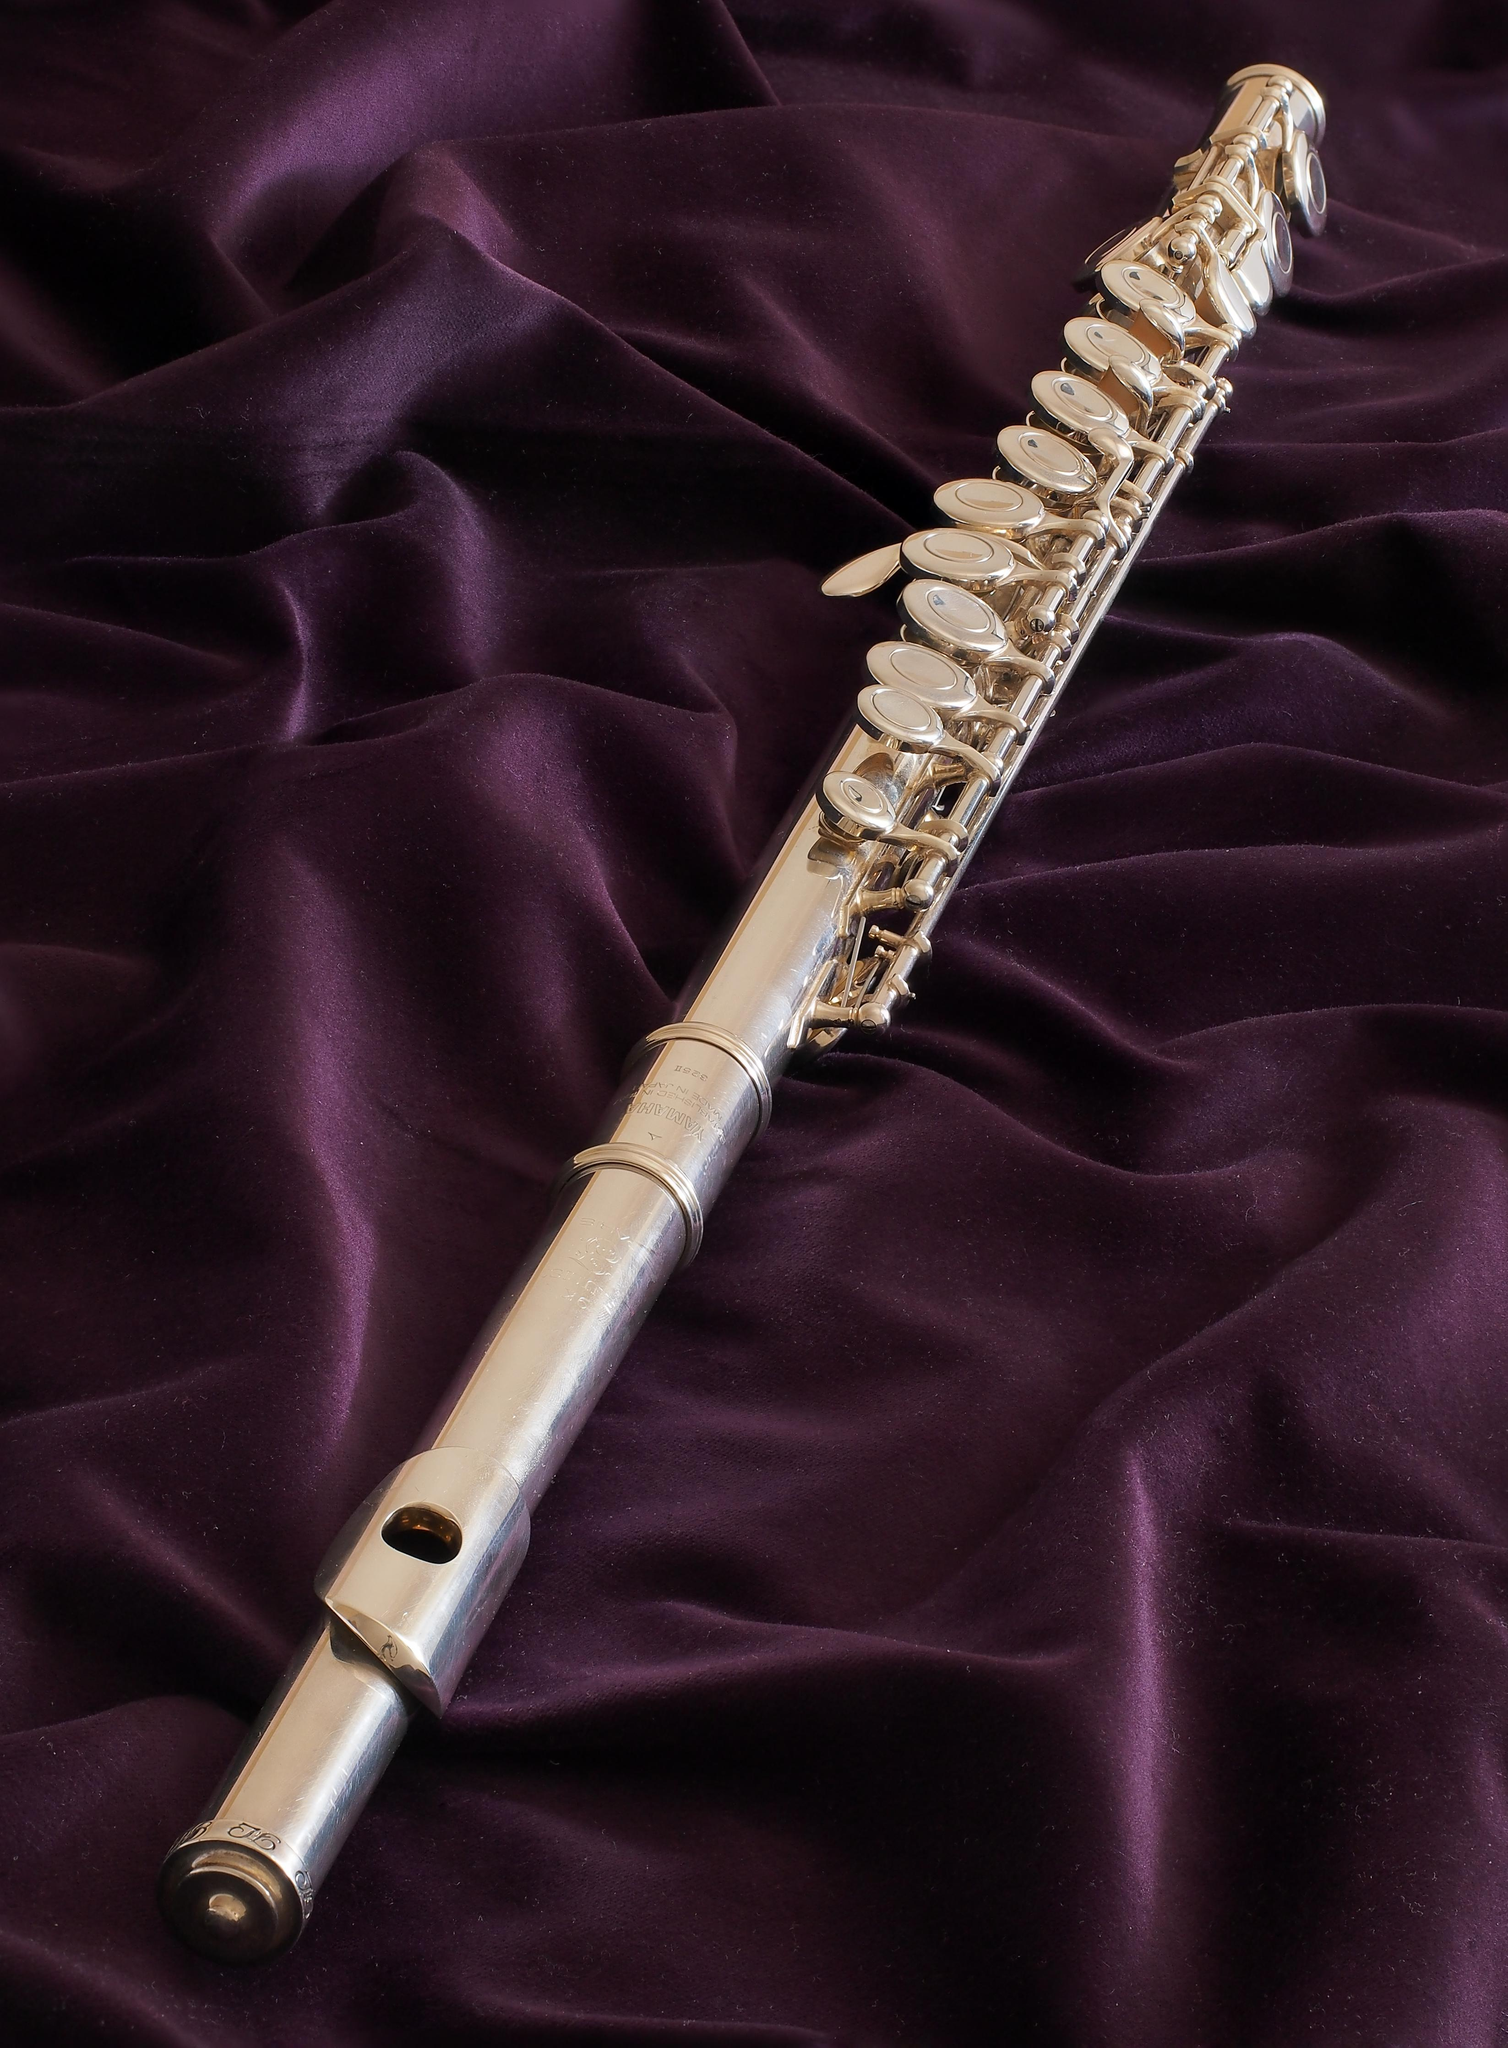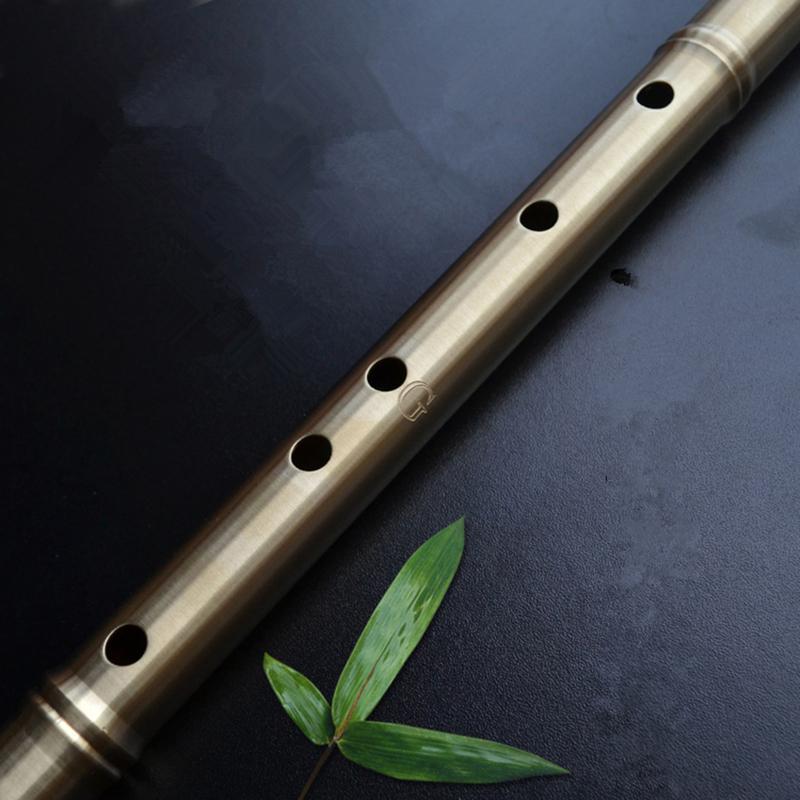The first image is the image on the left, the second image is the image on the right. Considering the images on both sides, is "The picture on the left shows exactly two flutes side by side." valid? Answer yes or no. No. The first image is the image on the left, the second image is the image on the right. Analyze the images presented: Is the assertion "There is a white flute." valid? Answer yes or no. No. 